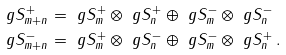<formula> <loc_0><loc_0><loc_500><loc_500>\ g S _ { m + n } ^ { + } & = \ g S _ { m } ^ { + } \otimes \ g S _ { n } ^ { + } \oplus \ g S _ { m } ^ { - } \otimes \ g S _ { n } ^ { - } \\ \ g S _ { m + n } ^ { - } & = \ g S _ { m } ^ { + } \otimes \ g S _ { n } ^ { - } \oplus \ g S _ { m } ^ { - } \otimes \ g S _ { n } ^ { + } \, .</formula> 